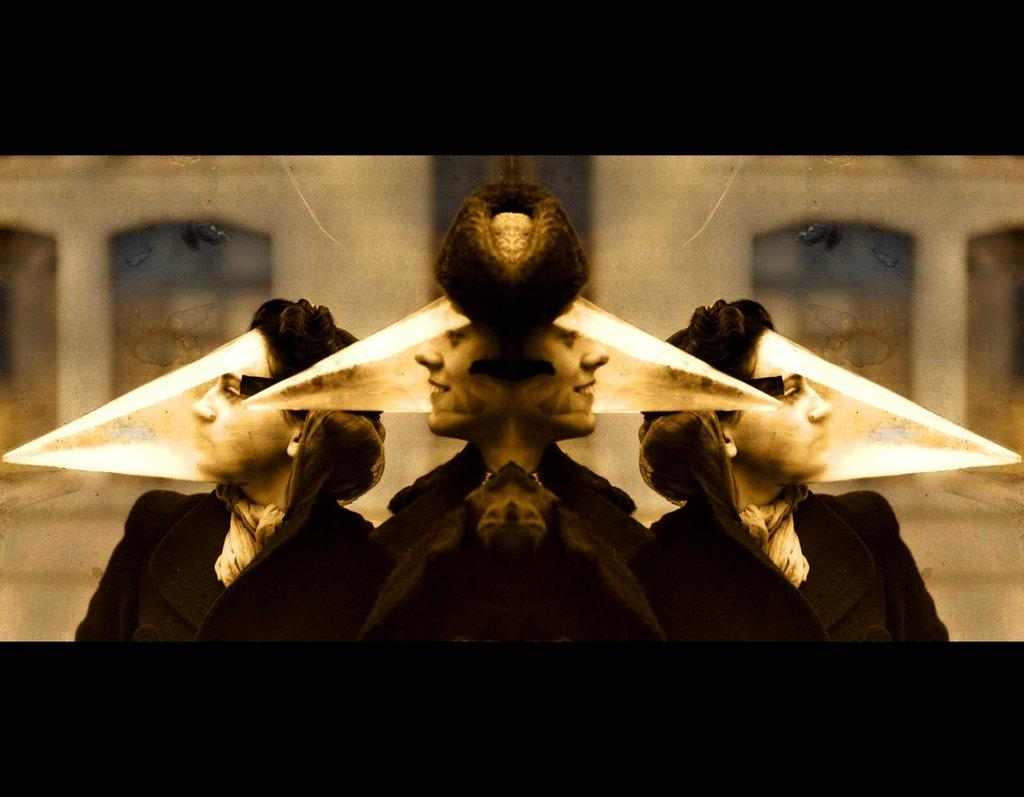What can be seen in the reflection of the image? There is a reflection of two persons in the image. What is visible in the background of the image? There is a building in the backdrop of the image. How would you describe the clarity of the image? The image is blurred. What advice is the quill giving to the visitor in the image? There is no quill or visitor present in the image, so it is not possible to answer that question. 